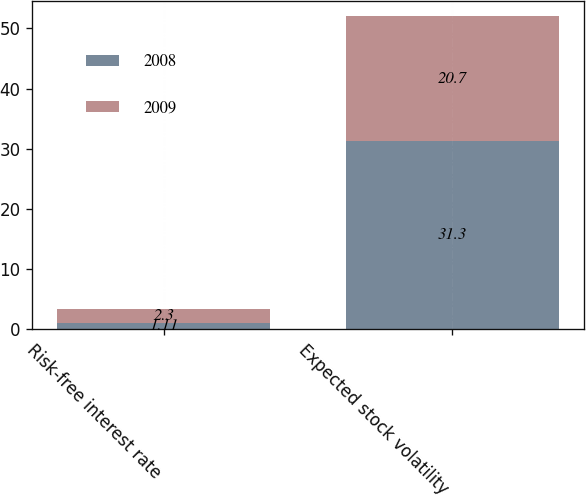<chart> <loc_0><loc_0><loc_500><loc_500><stacked_bar_chart><ecel><fcel>Risk-free interest rate<fcel>Expected stock volatility<nl><fcel>2008<fcel>1.11<fcel>31.3<nl><fcel>2009<fcel>2.3<fcel>20.7<nl></chart> 